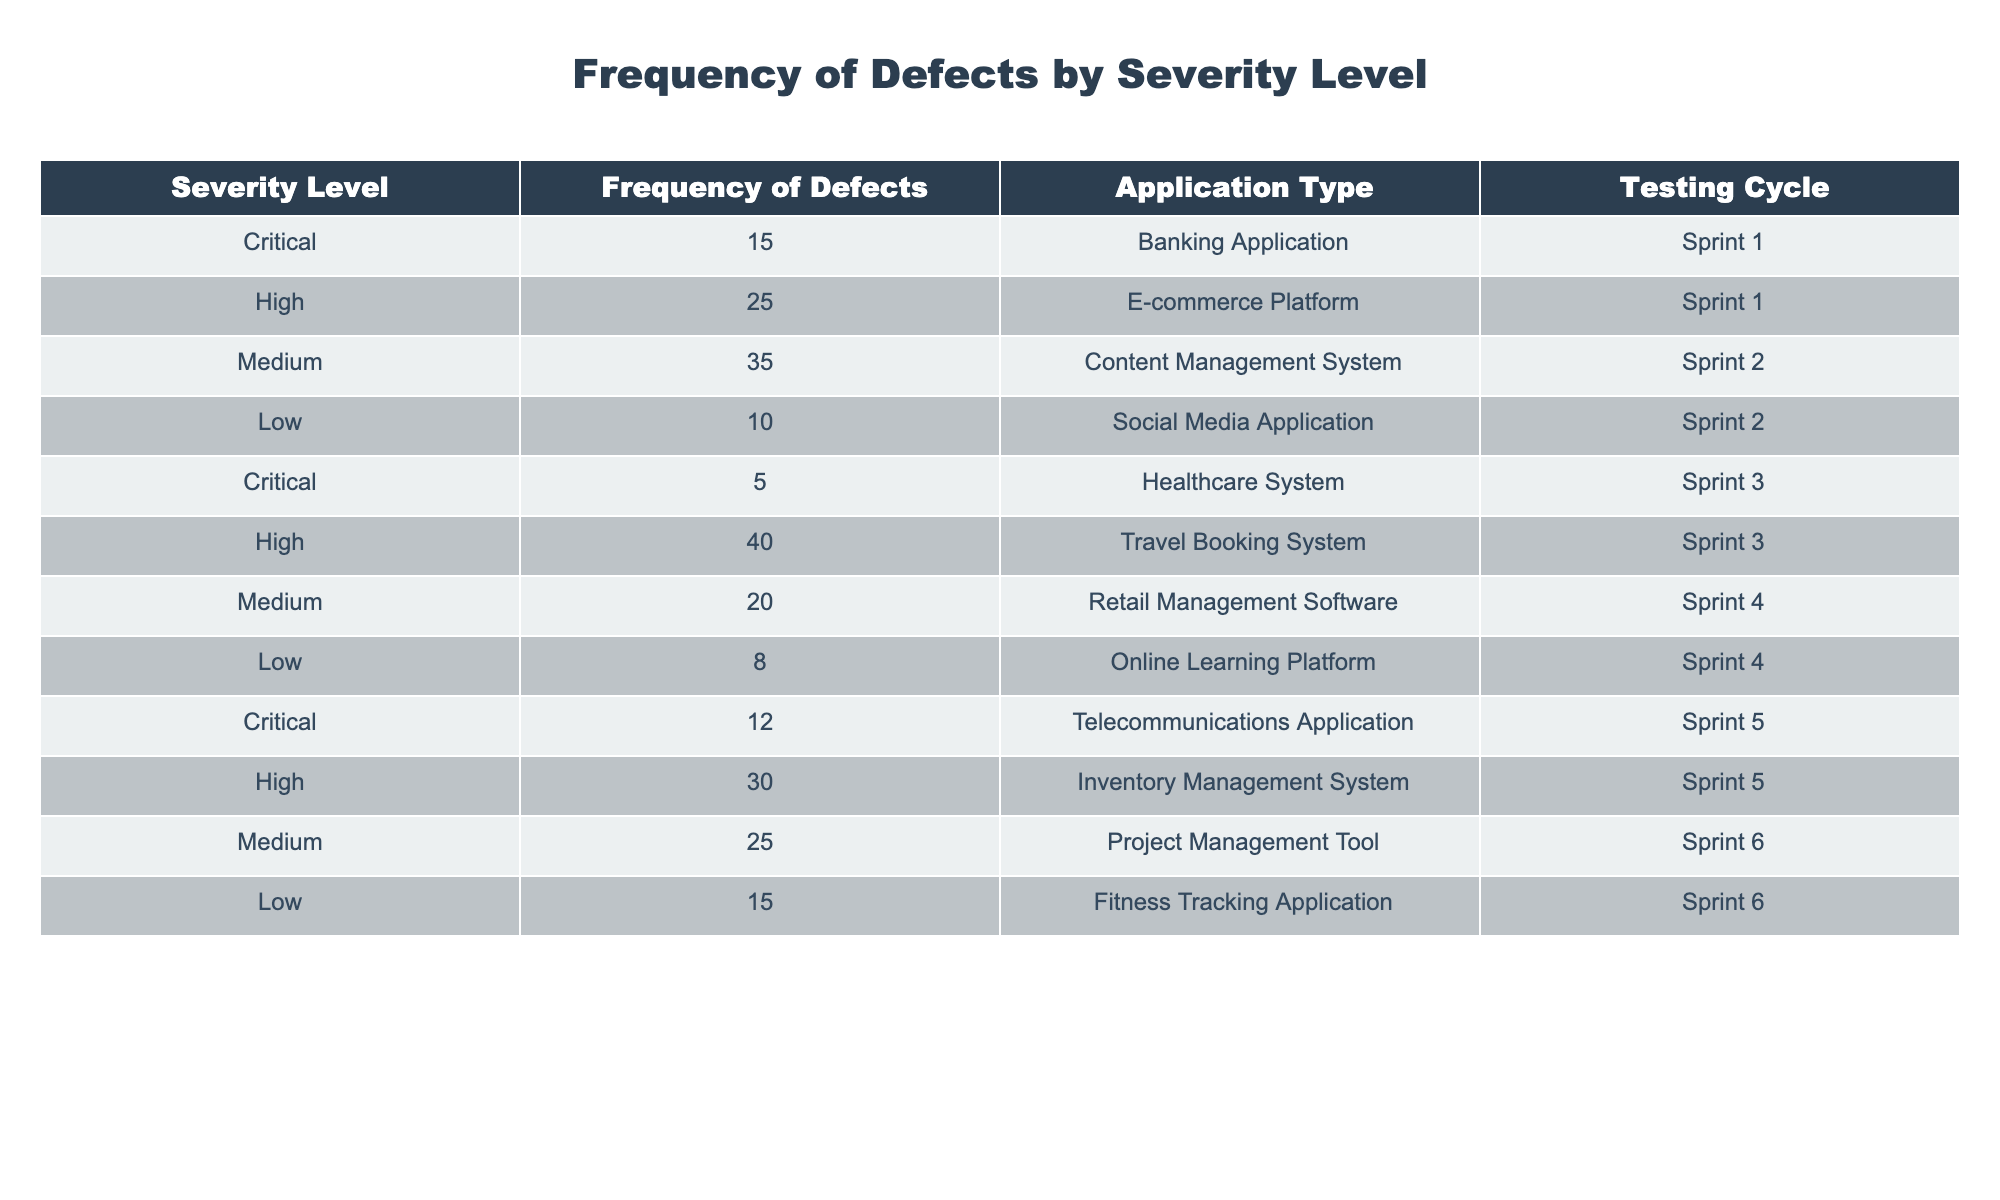What is the total number of critical defects reported? There are 3 rows where the severity level is marked as critical. The frequencies are 15, 5, and 12. Adding these values together: 15 + 5 + 12 = 32
Answer: 32 Which application type has the highest number of high severity defects? Looking at the rows with high severity, the frequencies are 25, 40, and 30, which correspond to E-commerce Platform, Travel Booking System, and Inventory Management System respectively. The highest frequency is 40, which belongs to the Travel Booking System.
Answer: Travel Booking System Is there a lower number of medium severity defects in Sprint 6 compared to Sprint 2? For Sprint 2, the number of medium severity defects is 35. In Sprint 6, the count is 25. Since 25 is less than 35, the statement is true.
Answer: Yes What is the average frequency of low severity defects found across all testing cycles? The frequencies for low severity defects are 10, 8, and 15. To find the average, we first calculate the sum: 10 + 8 + 15 = 33. There are 3 data points, so the average is 33/3 = 11.
Answer: 11 Are there more overall defects found in the Banking Application than in the Social Media Application? The Banking Application has 15 defects, while Social Media Application has 10 defects. Since 15 is greater than 10, the statement is true.
Answer: Yes Which testing cycle has the least number of defects from the medium severity category? The medium severity defects for each cycle are 35 (Sprint 2), 20 (Sprint 4), and 25 (Sprint 6). The least number is 20, which is from Sprint 4.
Answer: Sprint 4 How many total defects were reported for each severity level from the table? The total defects are: Critical (32), High (95), Medium (80), Low (33). Summing them gives a total of 32 + 95 + 80 + 33 = 240.
Answer: 240 In how many different application types were critical defects reported? Critical defects were found in 3 different application types: Banking Application, Healthcare System, and Telecommunications Application. Therefore, the count is 3.
Answer: 3 